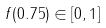Convert formula to latex. <formula><loc_0><loc_0><loc_500><loc_500>f ( 0 . 7 5 ) \in [ 0 , 1 ]</formula> 